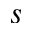<formula> <loc_0><loc_0><loc_500><loc_500>s</formula> 